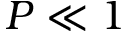<formula> <loc_0><loc_0><loc_500><loc_500>P \ll 1</formula> 